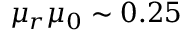Convert formula to latex. <formula><loc_0><loc_0><loc_500><loc_500>\mu _ { r } \mu _ { 0 } \sim 0 . 2 5</formula> 